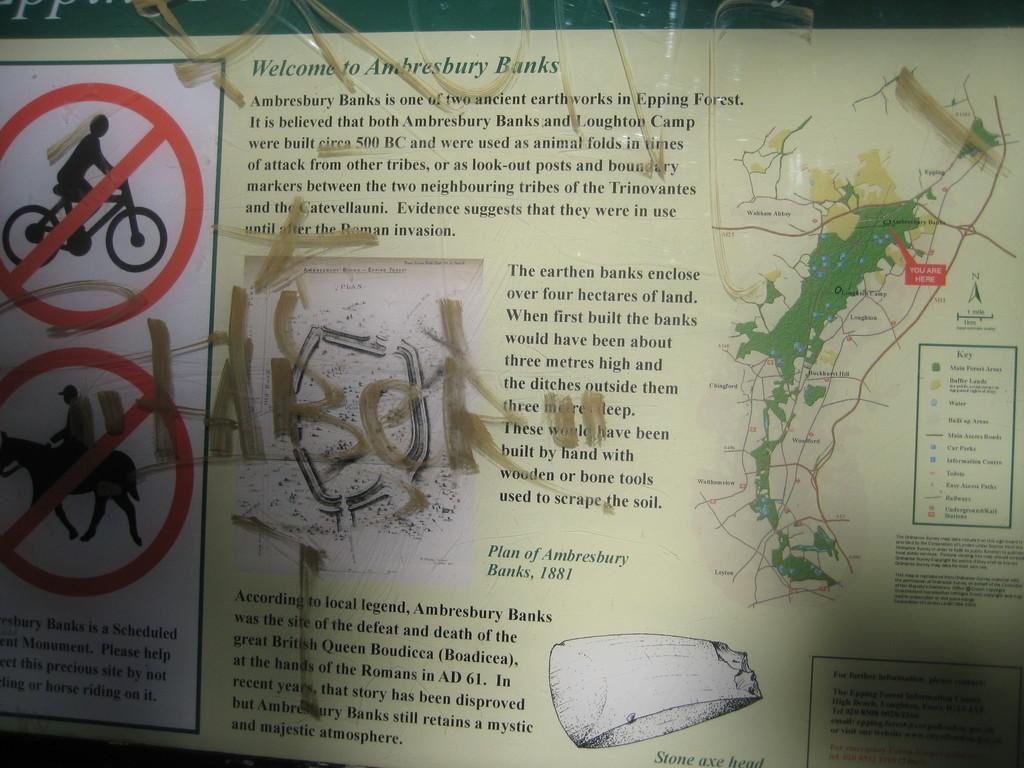<image>
Write a terse but informative summary of the picture. A graffitied sign reads Welcome to Ambresbury Banks. 